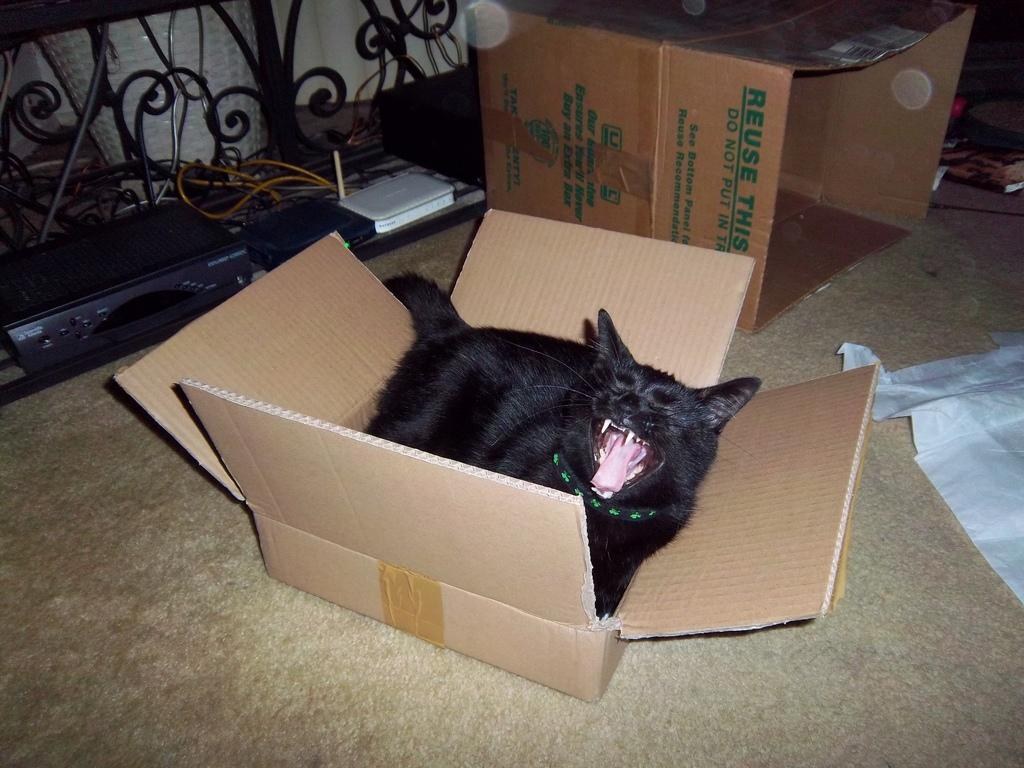<image>
Create a compact narrative representing the image presented. A black cat in a carboard box in front of another cardboard box that encourages you to reuse it. 